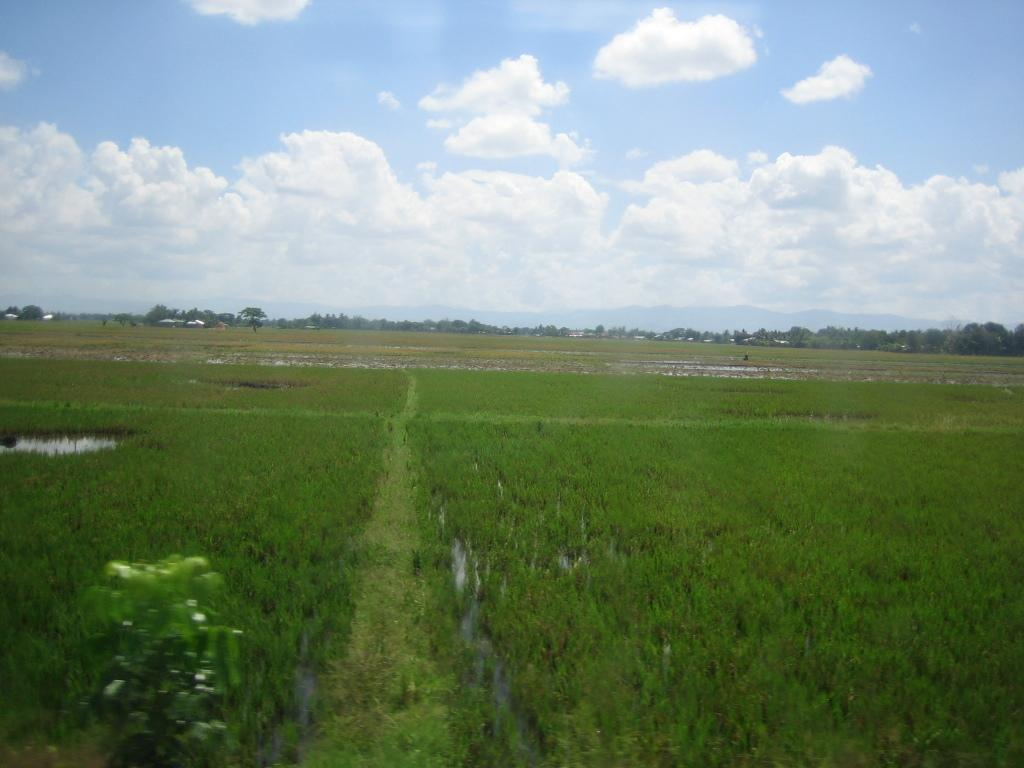What type of vegetation is present in the image? There is a plant and grass in the image. What can be seen in the background of the image? There are trees in the background of the image. How would you describe the sky in the image? The sky is cloudy in the image. What type of jelly can be seen on the furniture in the image? There is no jelly or furniture present in the image; it features a plant, grass, trees, and a cloudy sky. Is anyone driving a vehicle in the image? There is no vehicle or driving activity depicted in the image. 